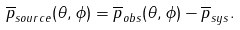<formula> <loc_0><loc_0><loc_500><loc_500>\overline { p } _ { s o u r c e } ( \theta , \phi ) = \overline { p } _ { o b s } ( \theta , \phi ) - \overline { p } _ { s y s } .</formula> 